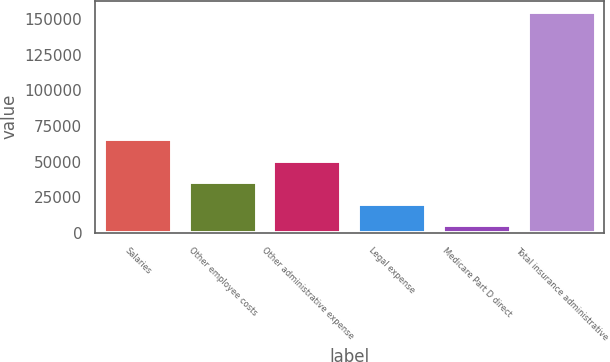Convert chart to OTSL. <chart><loc_0><loc_0><loc_500><loc_500><bar_chart><fcel>Salaries<fcel>Other employee costs<fcel>Other administrative expense<fcel>Legal expense<fcel>Medicare Part D direct<fcel>Total insurance administrative<nl><fcel>66031<fcel>35398.2<fcel>50389.8<fcel>20406.6<fcel>5415<fcel>155331<nl></chart> 